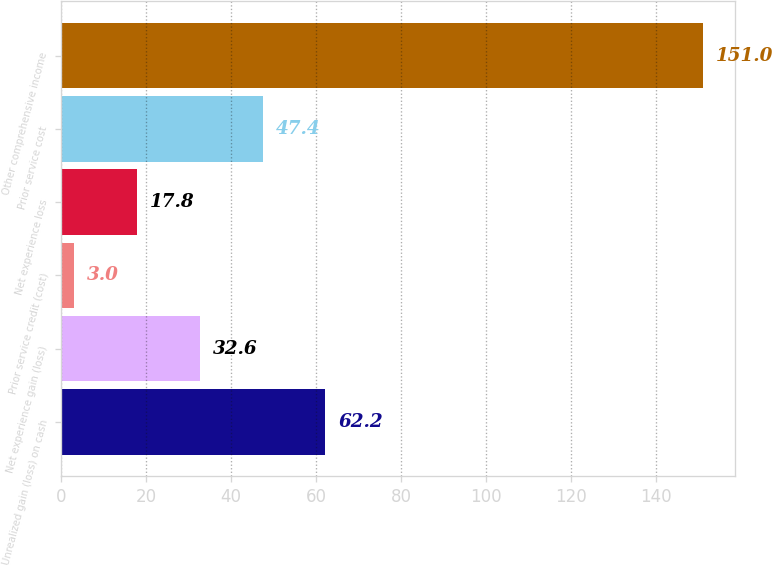<chart> <loc_0><loc_0><loc_500><loc_500><bar_chart><fcel>Unrealized gain (loss) on cash<fcel>Net experience gain (loss)<fcel>Prior service credit (cost)<fcel>Net experience loss<fcel>Prior service cost<fcel>Other comprehensive income<nl><fcel>62.2<fcel>32.6<fcel>3<fcel>17.8<fcel>47.4<fcel>151<nl></chart> 